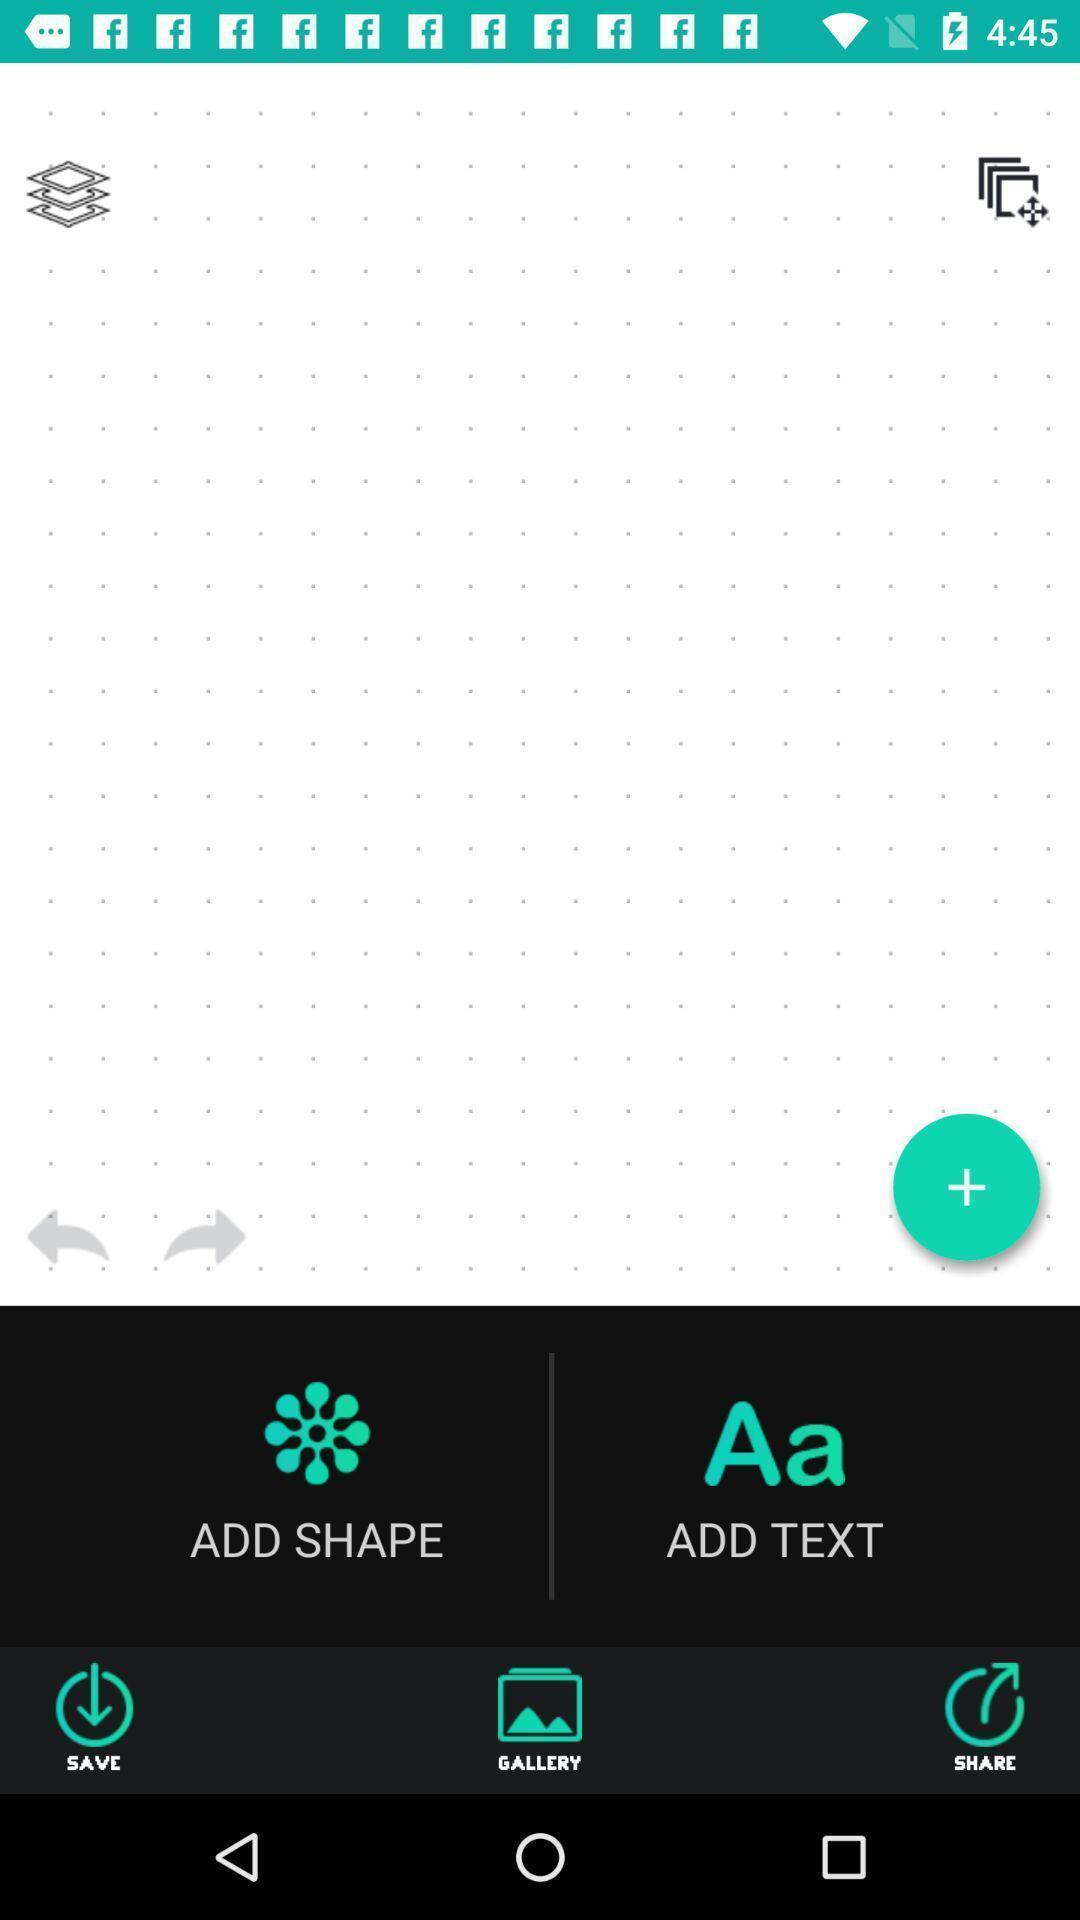Give me a summary of this screen capture. Screen page of a logo creator app. 